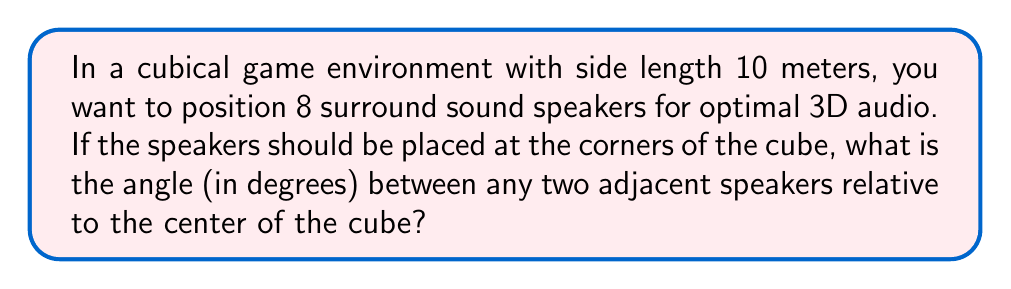What is the answer to this math problem? Let's approach this step-by-step:

1) In a cube, the speakers will be positioned at the 8 vertices. We need to find the angle between any two adjacent vertices, with the center of the cube as the vertex of this angle.

2) To calculate this, we can use the dot product formula for the angle between two vectors:

   $$\cos \theta = \frac{\vec{a} \cdot \vec{b}}{|\vec{a}||\vec{b}|}$$

3) Let's choose two adjacent vertices and the center of the cube:
   - Center: (5, 5, 5)
   - Vertex 1: (0, 0, 0)
   - Vertex 2: (10, 0, 0)

4) Create vectors from the center to each vertex:
   $$\vec{a} = (0-5, 0-5, 0-5) = (-5, -5, -5)$$
   $$\vec{b} = (10-5, 0-5, 0-5) = (5, -5, -5)$$

5) Calculate the dot product $\vec{a} \cdot \vec{b}$:
   $$\vec{a} \cdot \vec{b} = (-5)(5) + (-5)(-5) + (-5)(-5) = -25 + 25 + 25 = 25$$

6) Calculate the magnitudes:
   $$|\vec{a}| = |\vec{b}| = \sqrt{(-5)^2 + (-5)^2 + (-5)^2} = 5\sqrt{3}$$

7) Substitute into the formula:
   $$\cos \theta = \frac{25}{(5\sqrt{3})(5\sqrt{3})} = \frac{25}{75} = \frac{1}{3}$$

8) Take the inverse cosine (arccos) of both sides:
   $$\theta = \arccos(\frac{1}{3})$$

9) Convert to degrees:
   $$\theta = \arccos(\frac{1}{3}) \cdot \frac{180}{\pi} \approx 70.53°$$
Answer: $70.53°$ 